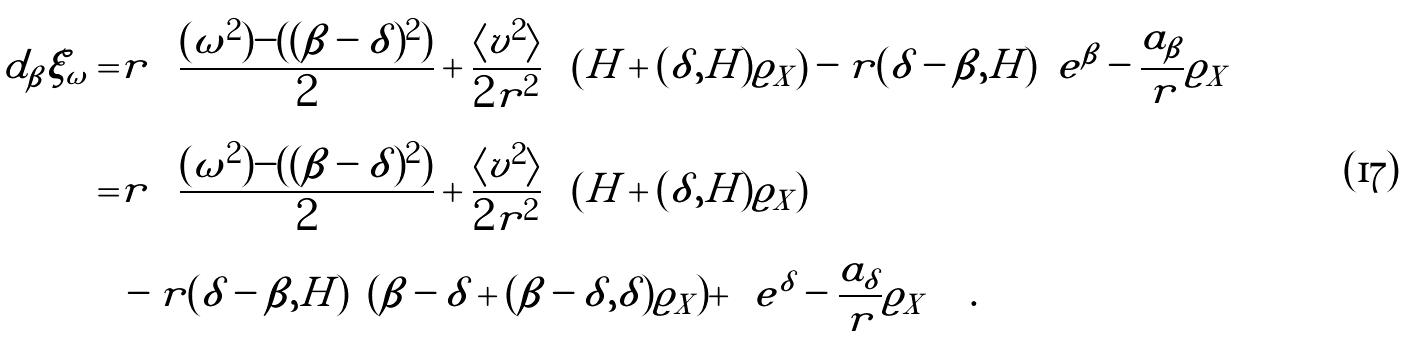Convert formula to latex. <formula><loc_0><loc_0><loc_500><loc_500>d _ { \beta } \xi _ { \omega } = & r \left ( \frac { ( \omega ^ { 2 } ) - ( ( \beta - \delta ) ^ { 2 } ) } { 2 } + \frac { \langle v ^ { 2 } \rangle } { 2 r ^ { 2 } } \right ) \left ( H + ( \delta , H ) \varrho _ { X } \right ) - r ( \delta - \beta , H ) \left ( e ^ { \beta } - \frac { a _ { \beta } } { r } \varrho _ { X } \right ) \\ = & r \left ( \frac { ( \omega ^ { 2 } ) - ( ( \beta - \delta ) ^ { 2 } ) } { 2 } + \frac { \langle v ^ { 2 } \rangle } { 2 r ^ { 2 } } \right ) \left ( H + ( \delta , H ) \varrho _ { X } \right ) \\ & - r ( \delta - \beta , H ) \left ( ( \beta - \delta + ( \beta - \delta , \delta ) \varrho _ { X } ) + \left ( e ^ { \delta } - \frac { a _ { \delta } } { r } \varrho _ { X } \right ) \right ) .</formula> 